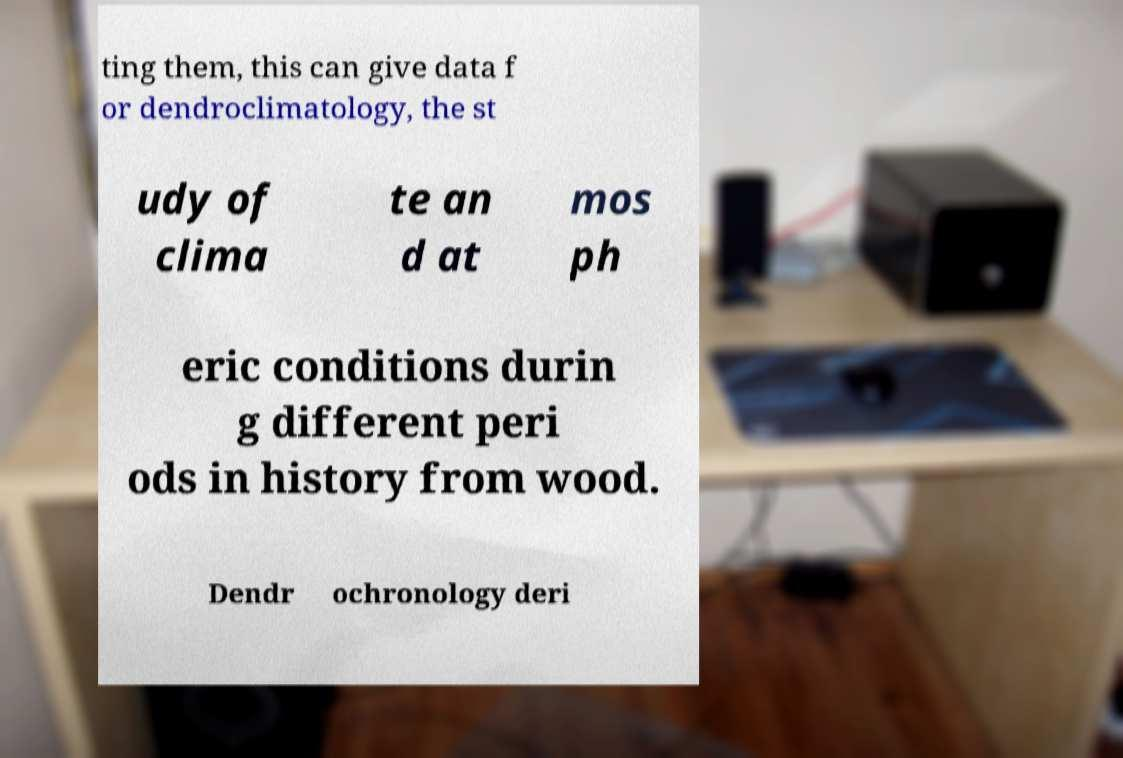For documentation purposes, I need the text within this image transcribed. Could you provide that? ting them, this can give data f or dendroclimatology, the st udy of clima te an d at mos ph eric conditions durin g different peri ods in history from wood. Dendr ochronology deri 